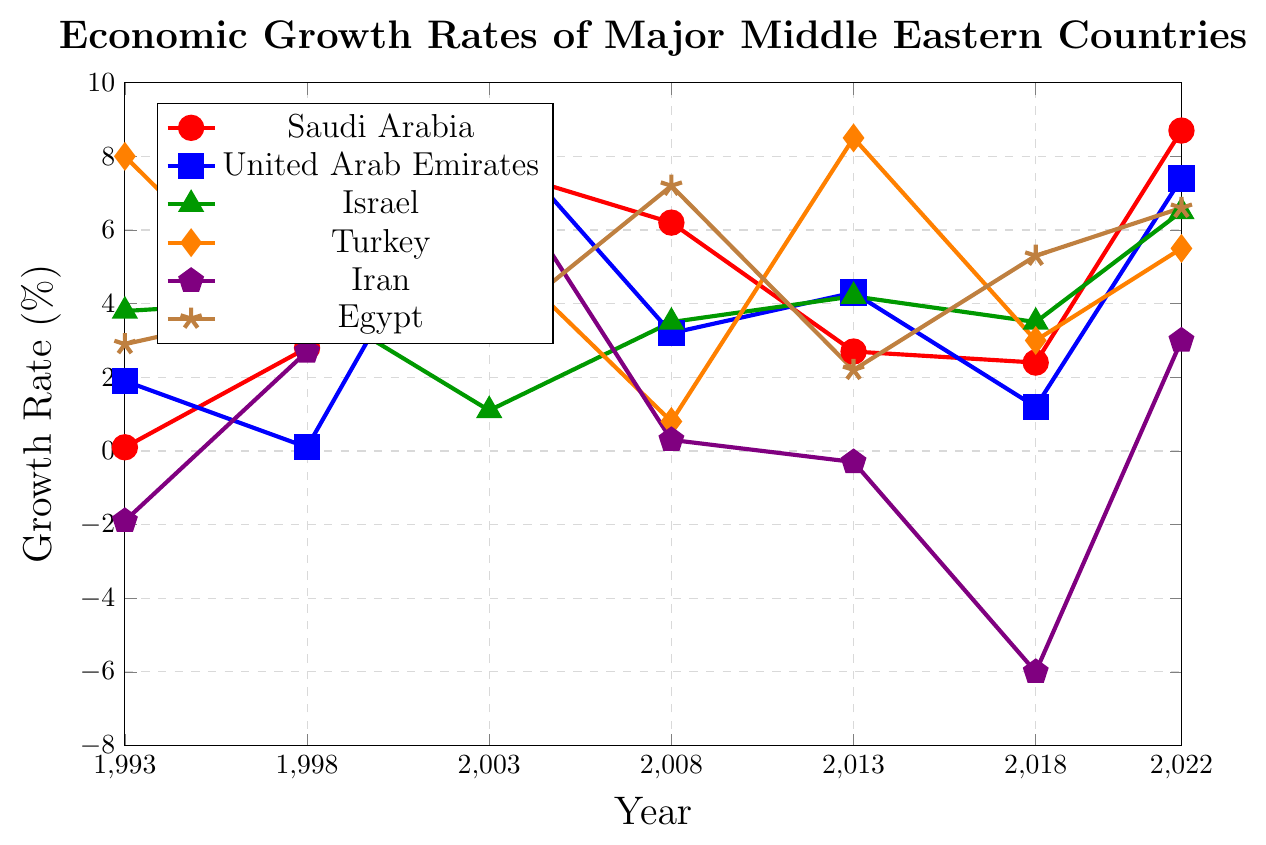Which country had the highest economic growth rate in 2022? Look at the year 2022 on the x-axis and find the highest point among all the lines. The red line representing Saudi Arabia is at the highest point, indicating a growth rate of 8.7%.
Answer: Saudi Arabia Which country experienced the largest drop in economic growth rate between 2013 and 2018? Compare the growth rates of each country in 2013 and 2018 and find the largest negative change. Iran's growth rate dropped from -0.3% to -6.0%, which is a decrease of 5.7%.
Answer: Iran What was the average growth rate of Israel from 1993 to 2022? Sum Israel’s growth rates from 1993, 1998, 2003, 2008, 2013, 2018, and 2022: (3.8 + 4.1 + 1.1 + 3.5 + 4.2 + 3.5 + 6.5). The total is 26.7. Then, divide by 7 (number of years) to get the average: 26.7 / 7 ≈ 3.81%.
Answer: 3.81% Compare the economic growth rates of Turkey and Egypt in 2008. Which country had a higher growth rate? Locate the year 2008 on the x-axis and compare the y-values for Turkey and Egypt. Turkey's growth rate is 0.8%, while Egypt's growth rate is 7.2%. Therefore, Egypt had a higher growth rate in 2008.
Answer: Egypt Which country had a negative growth rate in both 1993 and 2018? Look at the y-values for all countries in 1993 and 2018. Iran had negative growth rates in both 1993 (-1.9%) and 2018 (-6.0%).
Answer: Iran In which year did the United Arab Emirates experience its highest economic growth rate? Follow the blue line and identify the year where it reaches its highest point. The highest point is in 2003, where the growth rate is 8.8%.
Answer: 2003 Which two countries showed a similar trend in their growth rates from 1993 to 1998? Compare the slope and shape of the lines from 1993 to 1998. The green line (Israel) and orange line (Turkey) both show a decrease followed by a small increase.
Answer: Israel and Turkey What is the sum of the highest growth rates of Egypt and Iran in the entire timeline? Identify the highest growth rates of Egypt (7.2% in 2008) and Iran (8.0% in 2003). Add them together: 7.2 + 8.0 = 15.2%.
Answer: 15.2% Did any country maintain a consistent growth rate across all years shown? Review the lines for each country to see if any remain flat. All lines show variations in growth rates, so no country maintained a consistent growth rate.
Answer: No 